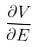<formula> <loc_0><loc_0><loc_500><loc_500>\frac { \partial V } { \partial E }</formula> 